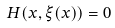Convert formula to latex. <formula><loc_0><loc_0><loc_500><loc_500>H ( x , \xi ( x ) ) = 0</formula> 